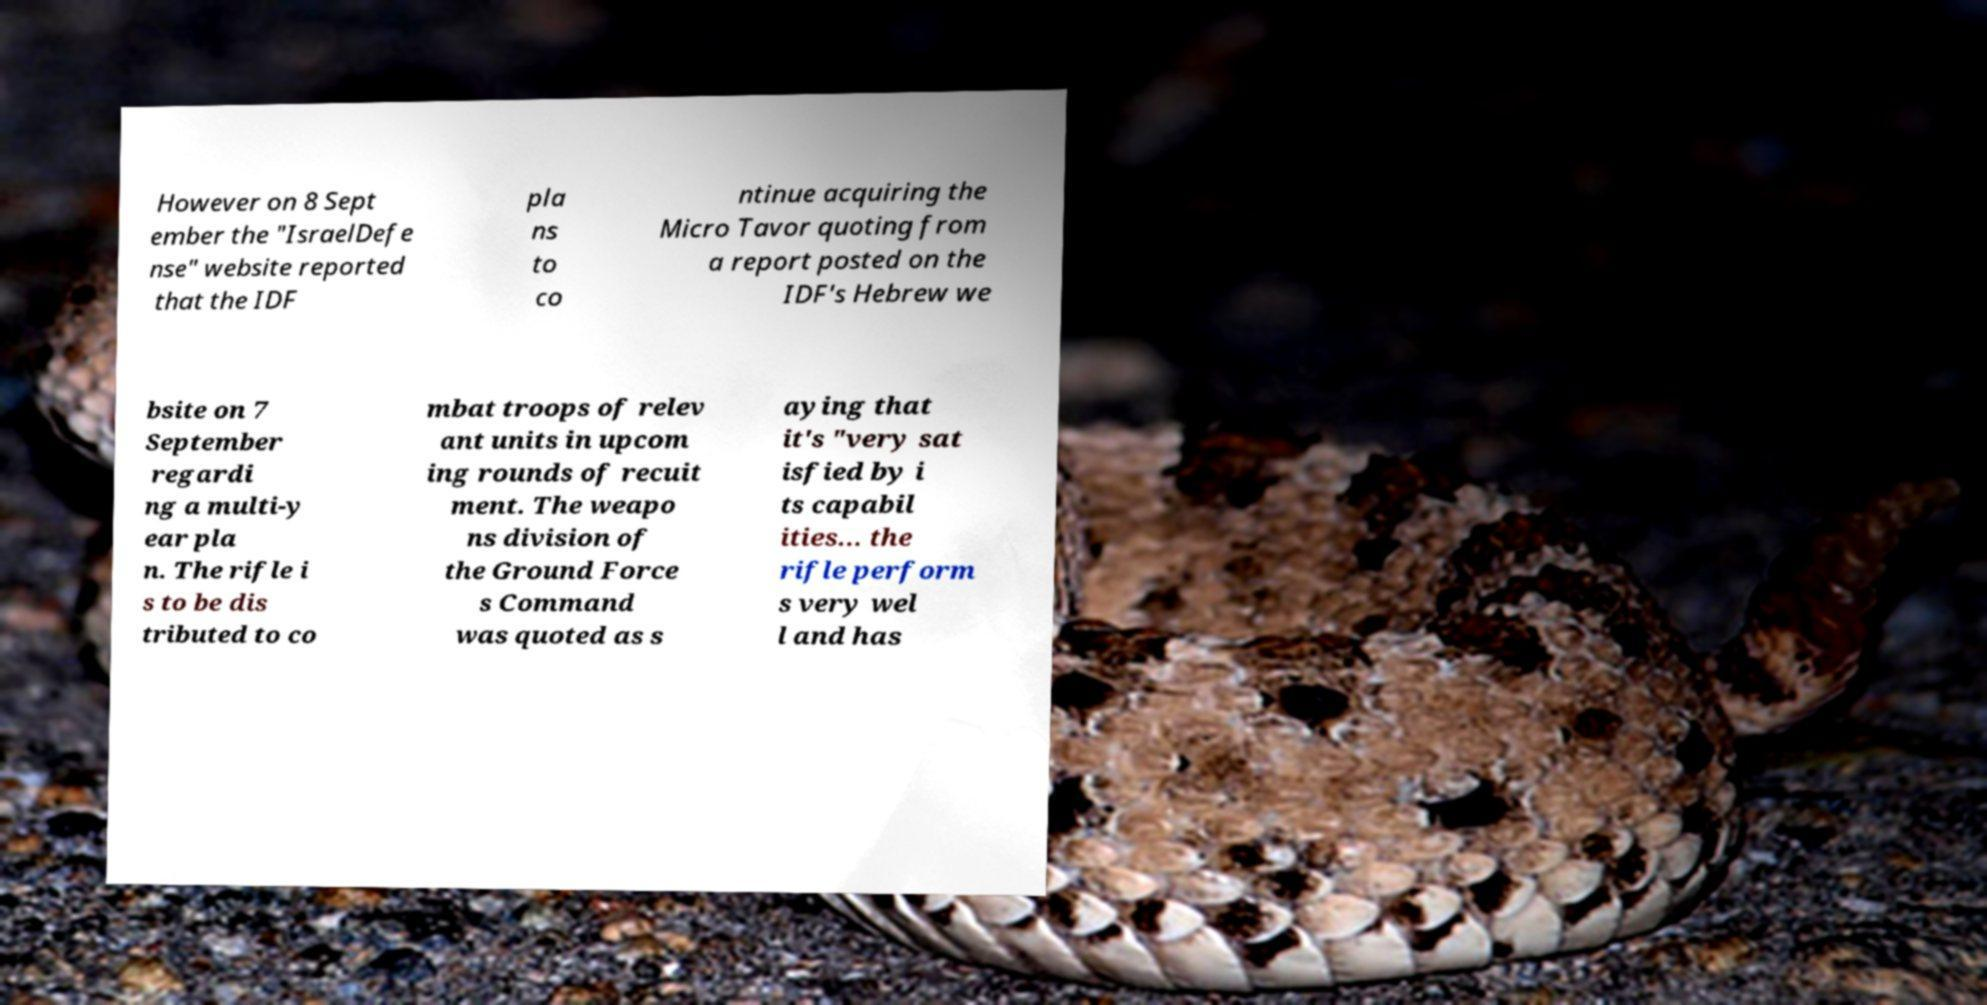For documentation purposes, I need the text within this image transcribed. Could you provide that? However on 8 Sept ember the "IsraelDefe nse" website reported that the IDF pla ns to co ntinue acquiring the Micro Tavor quoting from a report posted on the IDF's Hebrew we bsite on 7 September regardi ng a multi-y ear pla n. The rifle i s to be dis tributed to co mbat troops of relev ant units in upcom ing rounds of recuit ment. The weapo ns division of the Ground Force s Command was quoted as s aying that it's "very sat isfied by i ts capabil ities... the rifle perform s very wel l and has 